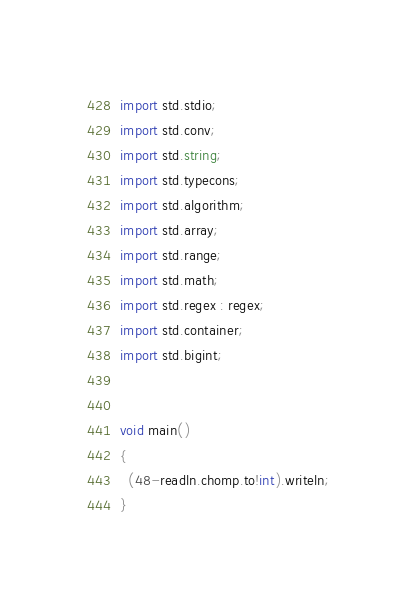Convert code to text. <code><loc_0><loc_0><loc_500><loc_500><_D_>import std.stdio;
import std.conv;
import std.string;
import std.typecons;
import std.algorithm;
import std.array;
import std.range;
import std.math;
import std.regex : regex;
import std.container;
import std.bigint;


void main()
{
  (48-readln.chomp.to!int).writeln;
}
</code> 